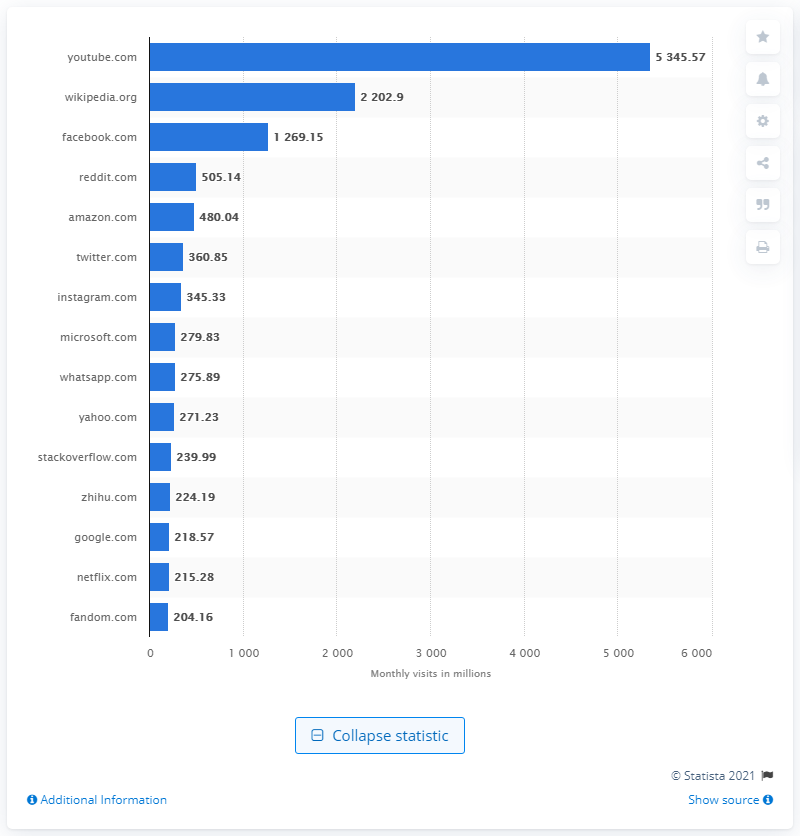Outline some significant characteristics in this image. In May 2020, Wikipedia received approximately 2,202.9 organic search visits. According to data from May 2020, YouTube generated a total of 53,45.57 global visits. 